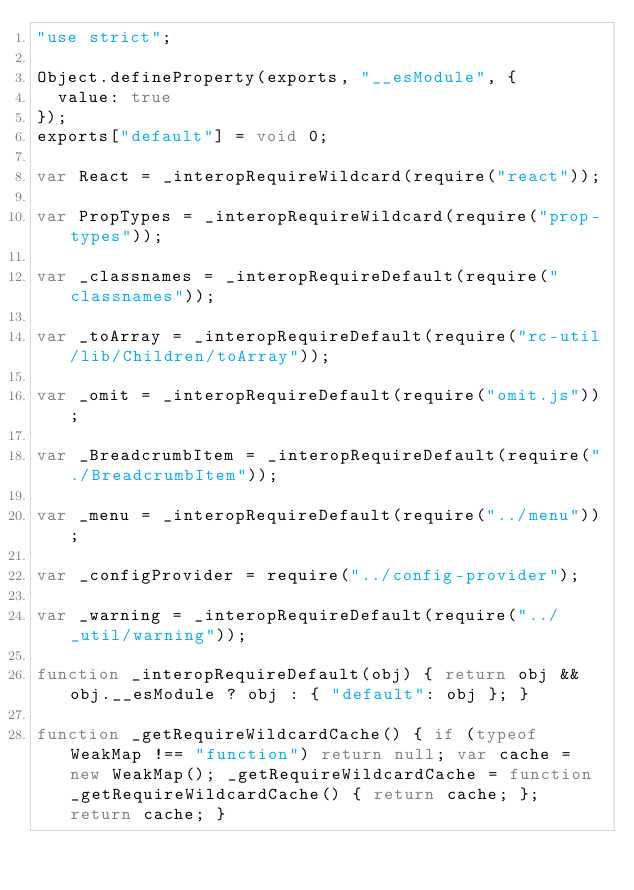Convert code to text. <code><loc_0><loc_0><loc_500><loc_500><_JavaScript_>"use strict";

Object.defineProperty(exports, "__esModule", {
  value: true
});
exports["default"] = void 0;

var React = _interopRequireWildcard(require("react"));

var PropTypes = _interopRequireWildcard(require("prop-types"));

var _classnames = _interopRequireDefault(require("classnames"));

var _toArray = _interopRequireDefault(require("rc-util/lib/Children/toArray"));

var _omit = _interopRequireDefault(require("omit.js"));

var _BreadcrumbItem = _interopRequireDefault(require("./BreadcrumbItem"));

var _menu = _interopRequireDefault(require("../menu"));

var _configProvider = require("../config-provider");

var _warning = _interopRequireDefault(require("../_util/warning"));

function _interopRequireDefault(obj) { return obj && obj.__esModule ? obj : { "default": obj }; }

function _getRequireWildcardCache() { if (typeof WeakMap !== "function") return null; var cache = new WeakMap(); _getRequireWildcardCache = function _getRequireWildcardCache() { return cache; }; return cache; }
</code> 